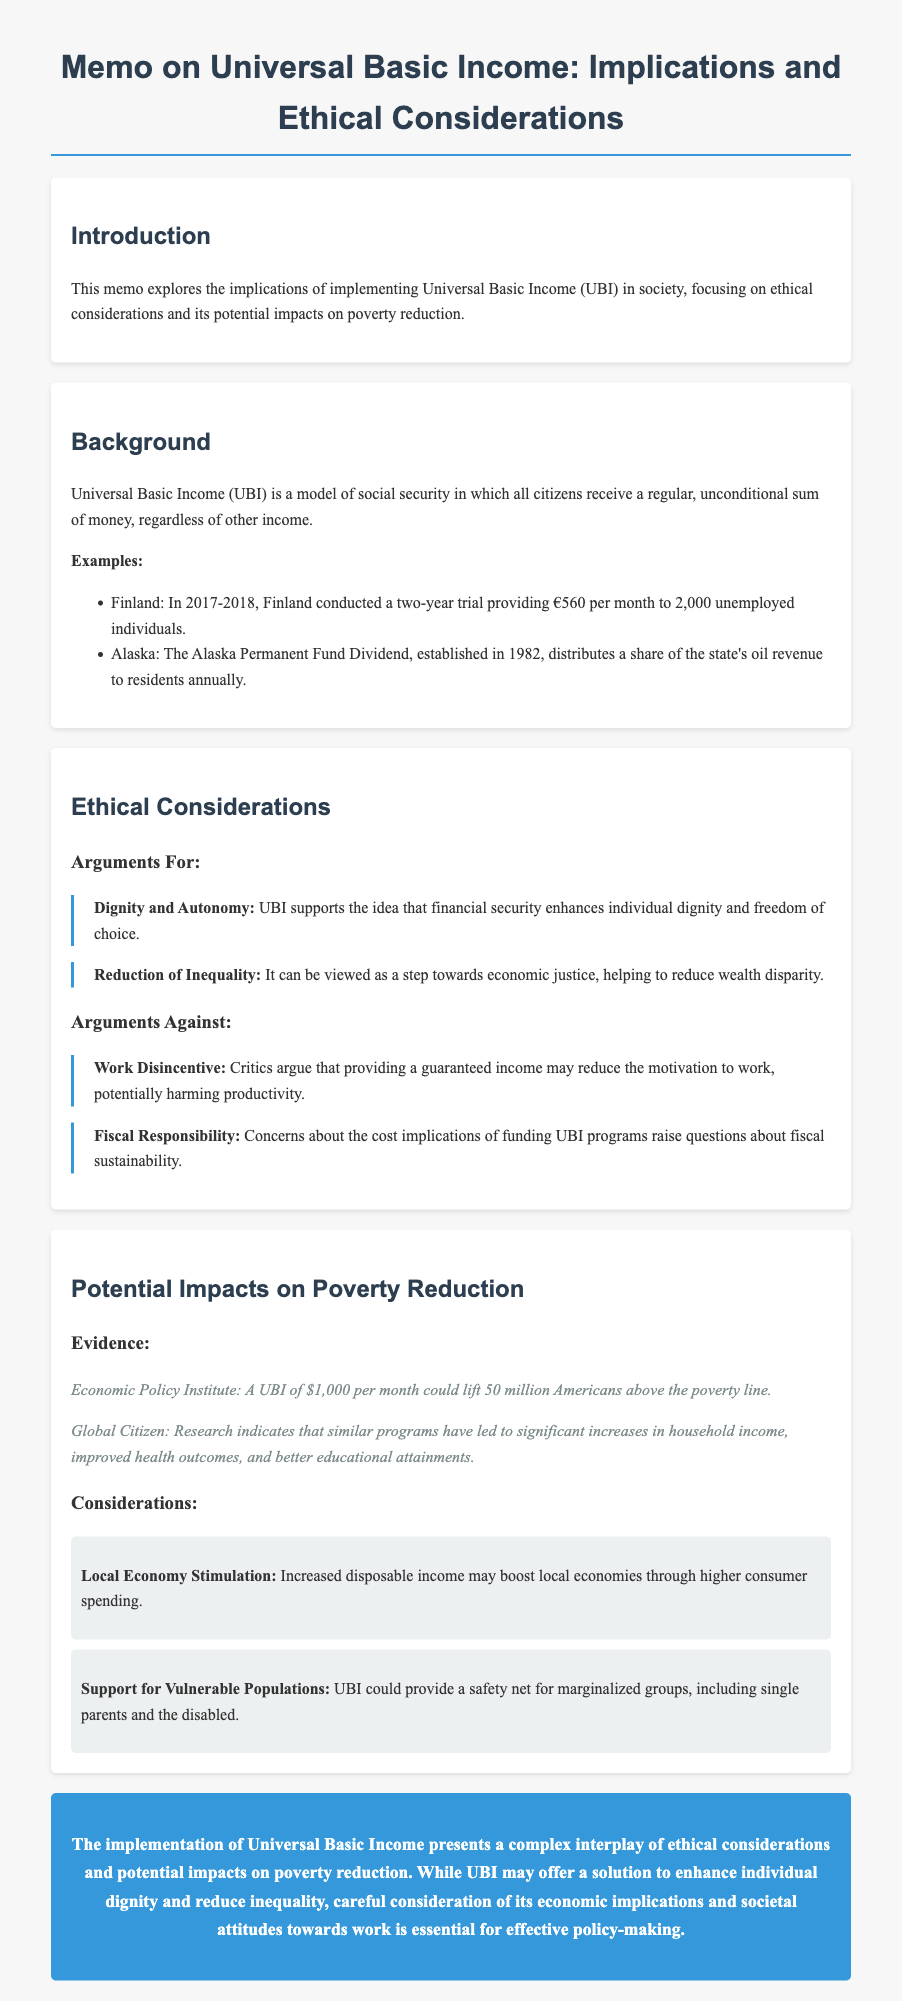What is UBI? UBI stands for Universal Basic Income, a model of social security where all citizens receive a regular, unconditional sum of money.
Answer: Universal Basic Income What was the amount provided in the Finland trial? The memo states that Finland provided €560 per month to 2,000 unemployed individuals during a trial.
Answer: €560 How many Americans could be lifted above the poverty line with a UBI of $1,000? According to the Economic Policy Institute, a UBI of $1,000 per month could lift 50 million Americans above the poverty line.
Answer: 50 million What is one argument for UBI related to personal dignity? One argument for UBI is that it supports the idea that financial security enhances individual dignity and freedom of choice.
Answer: Dignity and Autonomy What fiscal concern is raised against UBI? Critics raise concerns about the cost implications of funding UBI programs, which raises questions about fiscal sustainability.
Answer: Fiscal Responsibility What potential benefit does UBI have on local economies? The memo mentions that increased disposable income from UBI may boost local economies through higher consumer spending.
Answer: Local Economy Stimulation What trial example is used in the memo? Finland's two-year trial providing €560 per month to 2,000 unemployed individuals is mentioned as an example.
Answer: Finland Which group could benefit from UBI as mentioned in the memo? The memo states that UBI could provide a safety net for marginalized groups, including single parents and the disabled.
Answer: Vulnerable Populations 